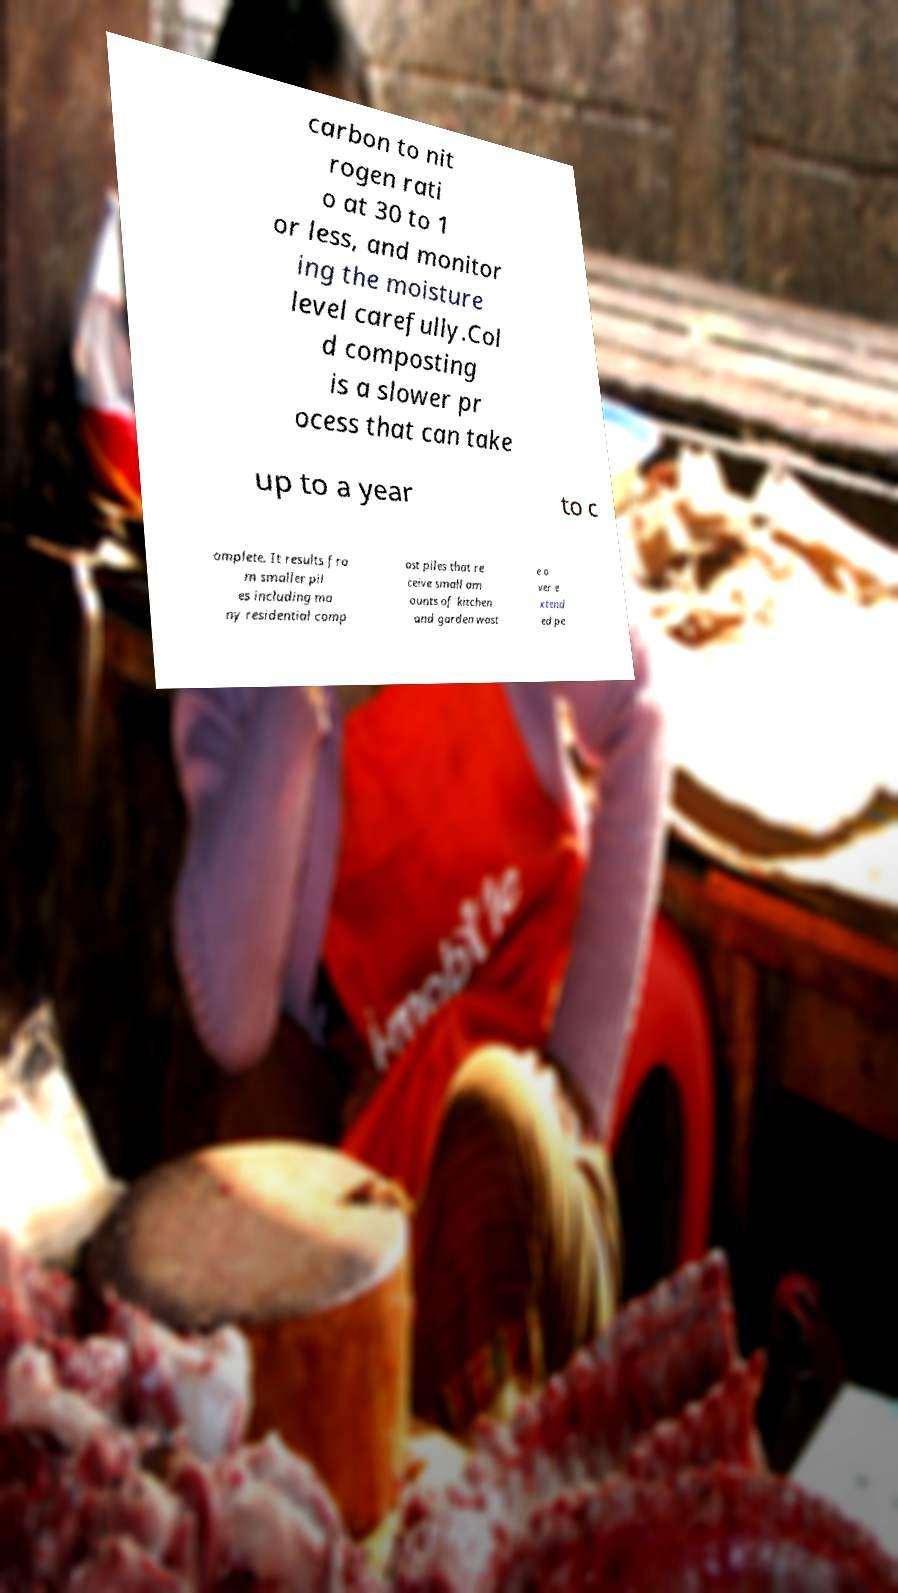I need the written content from this picture converted into text. Can you do that? carbon to nit rogen rati o at 30 to 1 or less, and monitor ing the moisture level carefully.Col d composting is a slower pr ocess that can take up to a year to c omplete. It results fro m smaller pil es including ma ny residential comp ost piles that re ceive small am ounts of kitchen and garden wast e o ver e xtend ed pe 